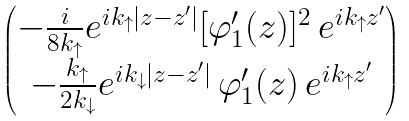Convert formula to latex. <formula><loc_0><loc_0><loc_500><loc_500>\begin{pmatrix} - \frac { i } { 8 k _ { \uparrow } } e ^ { i k _ { \uparrow } | z - z ^ { \prime } | } [ \varphi ^ { \prime } _ { 1 } ( z ) ] ^ { 2 } \, e ^ { i k _ { \uparrow } z ^ { \prime } } \\ - \frac { k _ { \uparrow } } { 2 k _ { \downarrow } } e ^ { i k _ { \downarrow } | z - z ^ { \prime } | } \, \varphi ^ { \prime } _ { 1 } ( z ) \, e ^ { i k _ { \uparrow } z ^ { \prime } } \end{pmatrix}</formula> 